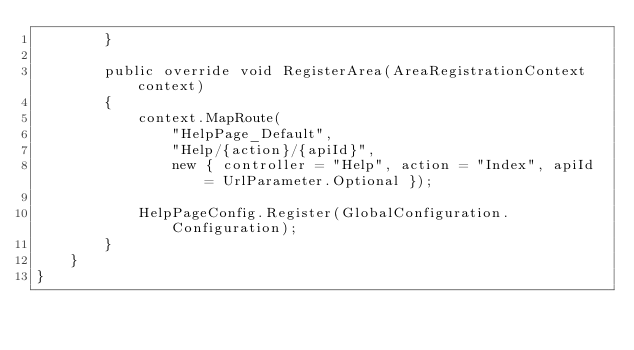Convert code to text. <code><loc_0><loc_0><loc_500><loc_500><_C#_>        }

        public override void RegisterArea(AreaRegistrationContext context)
        {
            context.MapRoute(
                "HelpPage_Default",
                "Help/{action}/{apiId}",
                new { controller = "Help", action = "Index", apiId = UrlParameter.Optional });

            HelpPageConfig.Register(GlobalConfiguration.Configuration);
        }
    }
}</code> 